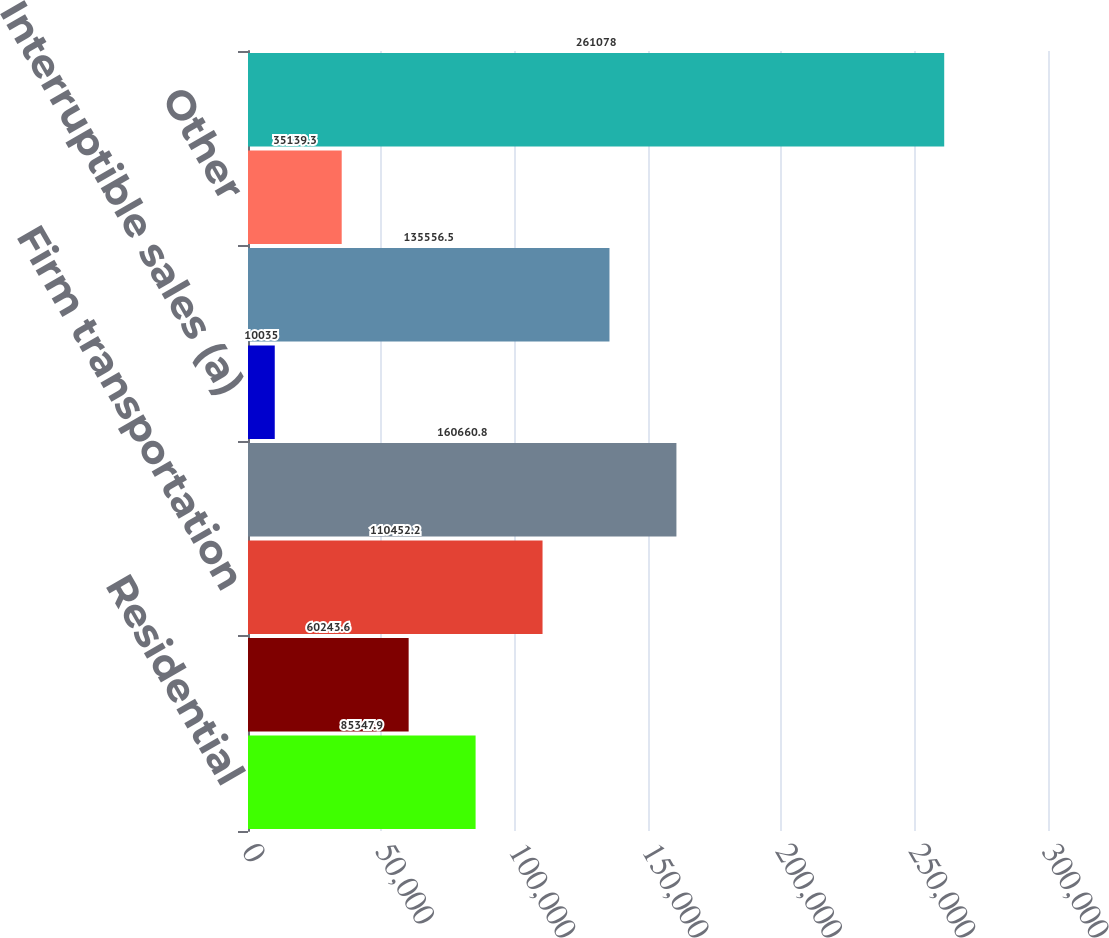<chart> <loc_0><loc_0><loc_500><loc_500><bar_chart><fcel>Residential<fcel>General<fcel>Firm transportation<fcel>Total firm sales and<fcel>Interruptible sales (a)<fcel>Generation plants<fcel>Other<fcel>Total<nl><fcel>85347.9<fcel>60243.6<fcel>110452<fcel>160661<fcel>10035<fcel>135556<fcel>35139.3<fcel>261078<nl></chart> 